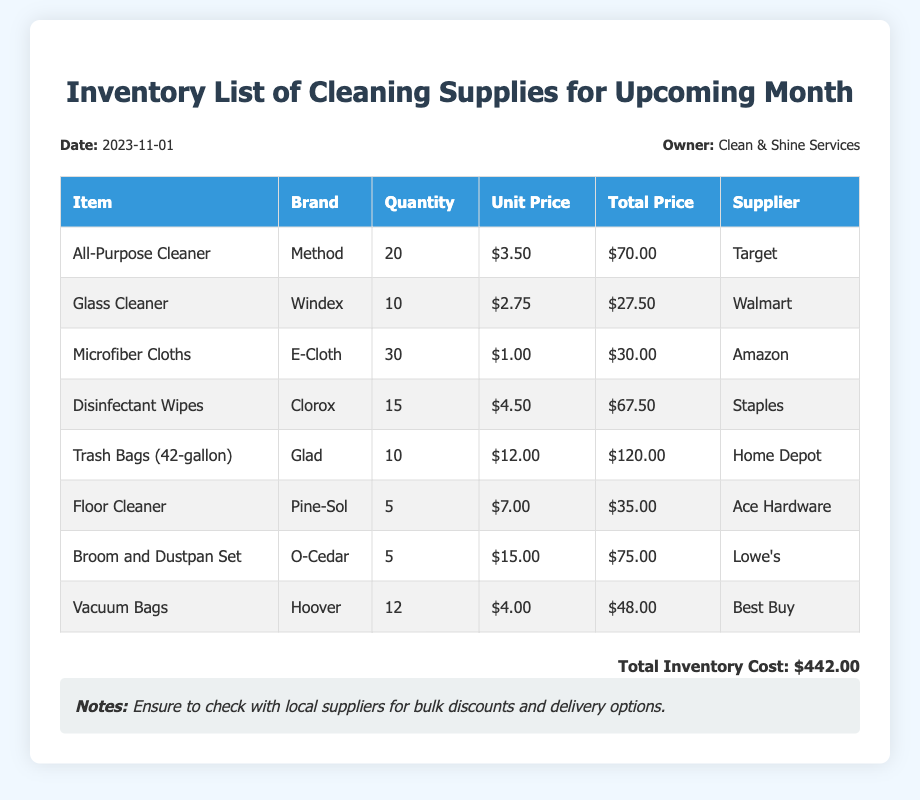What is the date of the inventory list? The date is specified in the header of the document, which is November 1, 2023.
Answer: November 1, 2023 How many All-Purpose Cleaners are required? The quantity required for All-Purpose Cleaner is listed in the table as 20.
Answer: 20 What is the total cost for Disinfectant Wipes? The total cost for Disinfectant Wipes can be found in the total price column of the table, which is $67.50.
Answer: $67.50 Who is the supplier for Microfiber Cloths? The supplier listed for Microfiber Cloths in the document is Amazon.
Answer: Amazon What is the unit price of Trash Bags? The unit price for Trash Bags is specified in the table as $12.00.
Answer: $12.00 How many different suppliers are listed in the inventory? The document contains suppliers for each item, which totals to six different suppliers.
Answer: 6 What is the total inventory cost? The total inventory cost is summarized at the end of the document, which is $442.00.
Answer: $442.00 Is there a note about checking local suppliers? The document includes a note that mentions checking with local suppliers for discounts and delivery.
Answer: Yes 